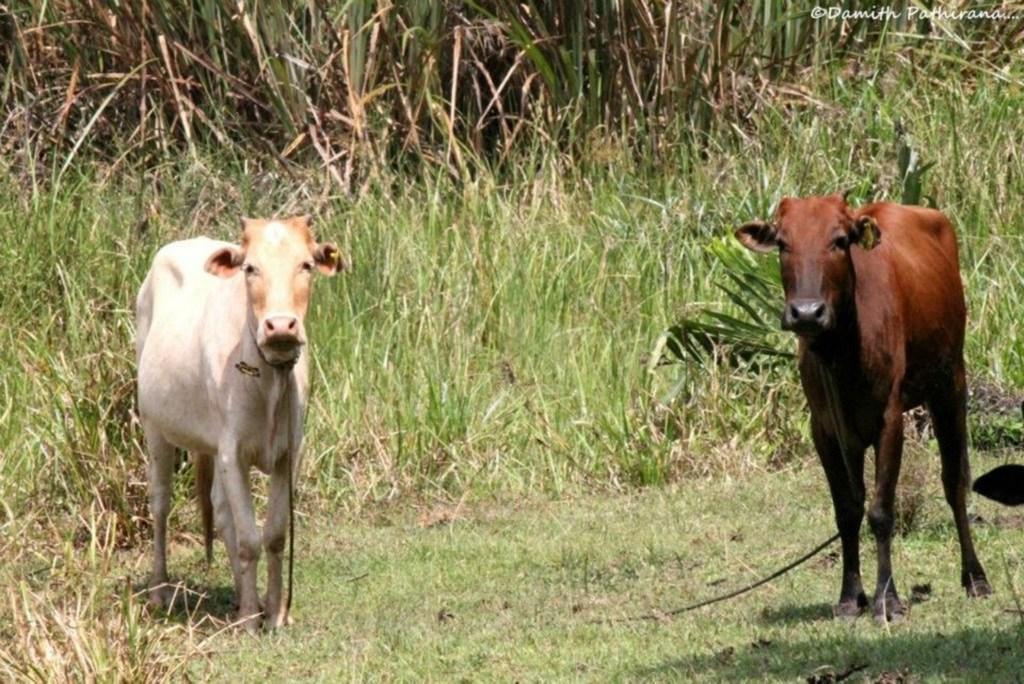Describe this image in one or two sentences. In the picture there are two calves standing they are tired with a rope,there is a grass near to the calf's there are some fields near to the calf's. 